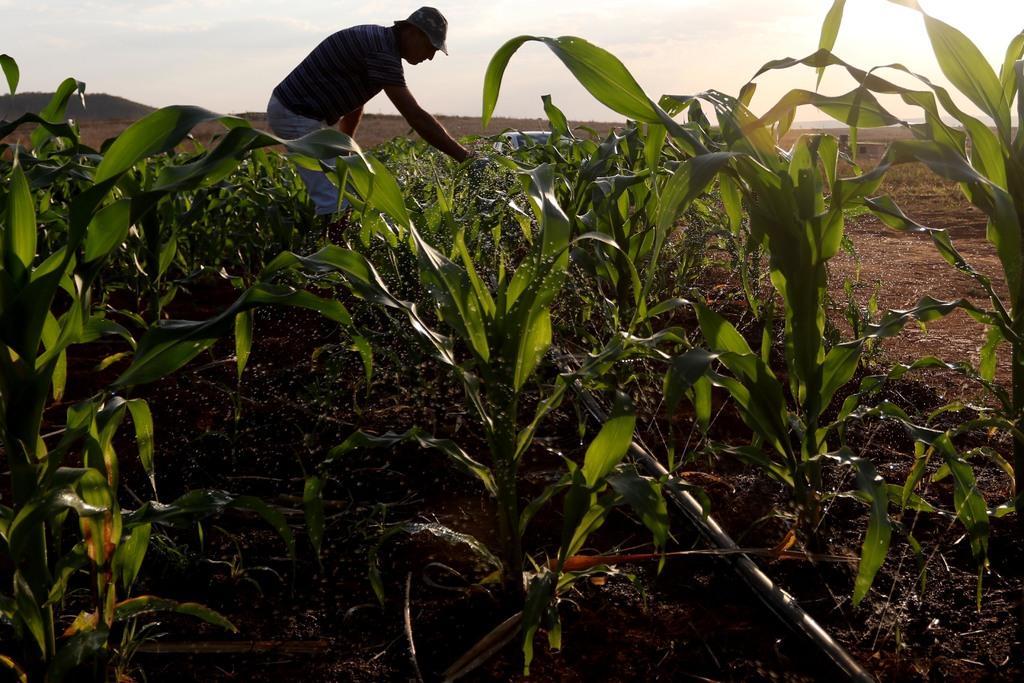Describe this image in one or two sentences. This picture shows a man standing and he is touching the plants with his hand and he wore a cap on his head and we see a cloudy sky. 